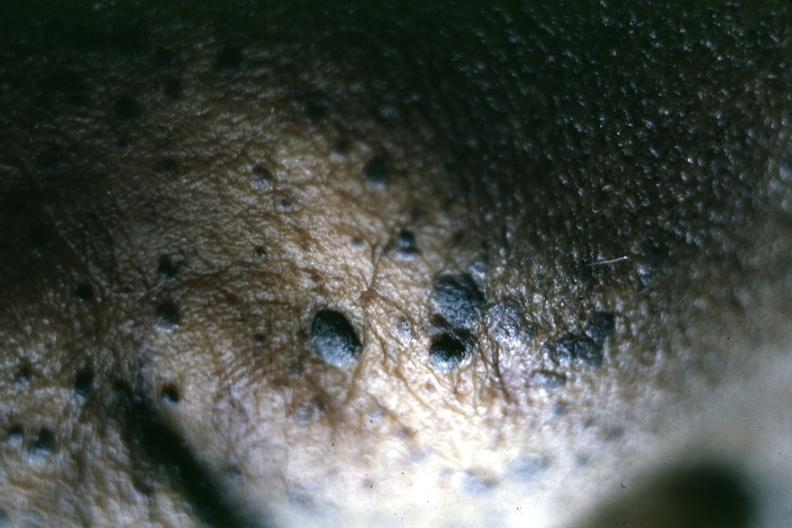what is present?
Answer the question using a single word or phrase. Seborrheic keratosis 